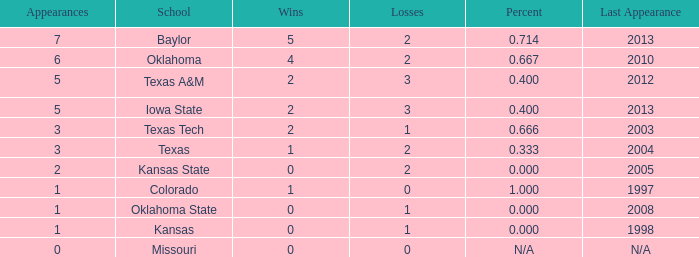667 success-failure ratio? 1.0. 